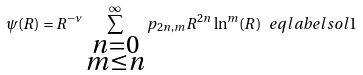Convert formula to latex. <formula><loc_0><loc_0><loc_500><loc_500>\psi ( R ) = R ^ { - \nu } \sum _ { \substack { n = 0 \\ m \leq n } } ^ { \infty } p _ { 2 n , m } R ^ { 2 n } \ln ^ { m } ( R ) \ e q l a b e l { s o l 1 }</formula> 